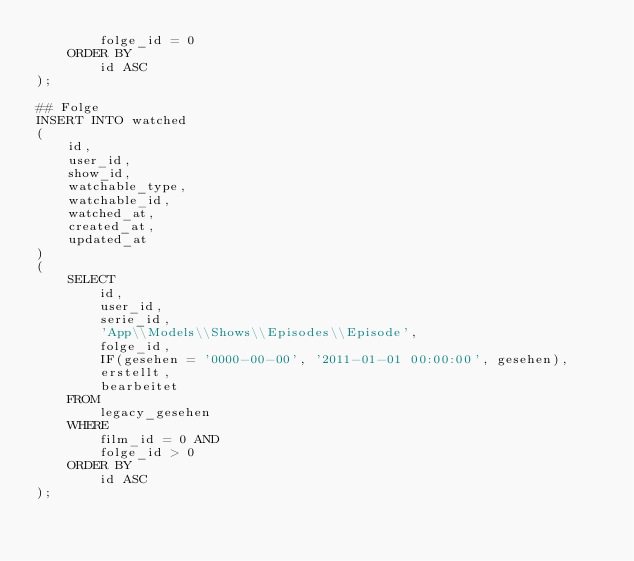Convert code to text. <code><loc_0><loc_0><loc_500><loc_500><_SQL_>        folge_id = 0
    ORDER BY
        id ASC
);

## Folge
INSERT INTO watched
(
    id,
    user_id,
    show_id,
    watchable_type,
    watchable_id,
    watched_at,
    created_at,
    updated_at
)
(
    SELECT
        id,
        user_id,
        serie_id,
        'App\\Models\\Shows\\Episodes\\Episode',
        folge_id,
        IF(gesehen = '0000-00-00', '2011-01-01 00:00:00', gesehen),
        erstellt,
        bearbeitet
    FROM
        legacy_gesehen
    WHERE
        film_id = 0 AND
        folge_id > 0
    ORDER BY
        id ASC
);</code> 